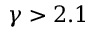Convert formula to latex. <formula><loc_0><loc_0><loc_500><loc_500>\gamma > 2 . 1</formula> 